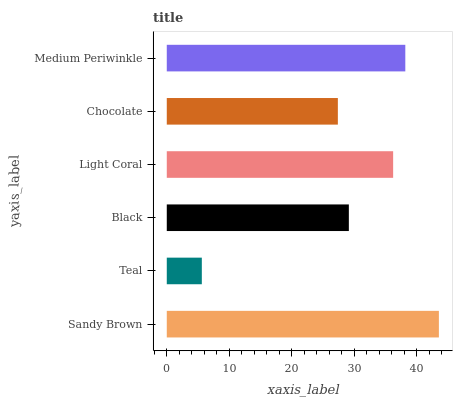Is Teal the minimum?
Answer yes or no. Yes. Is Sandy Brown the maximum?
Answer yes or no. Yes. Is Black the minimum?
Answer yes or no. No. Is Black the maximum?
Answer yes or no. No. Is Black greater than Teal?
Answer yes or no. Yes. Is Teal less than Black?
Answer yes or no. Yes. Is Teal greater than Black?
Answer yes or no. No. Is Black less than Teal?
Answer yes or no. No. Is Light Coral the high median?
Answer yes or no. Yes. Is Black the low median?
Answer yes or no. Yes. Is Sandy Brown the high median?
Answer yes or no. No. Is Chocolate the low median?
Answer yes or no. No. 